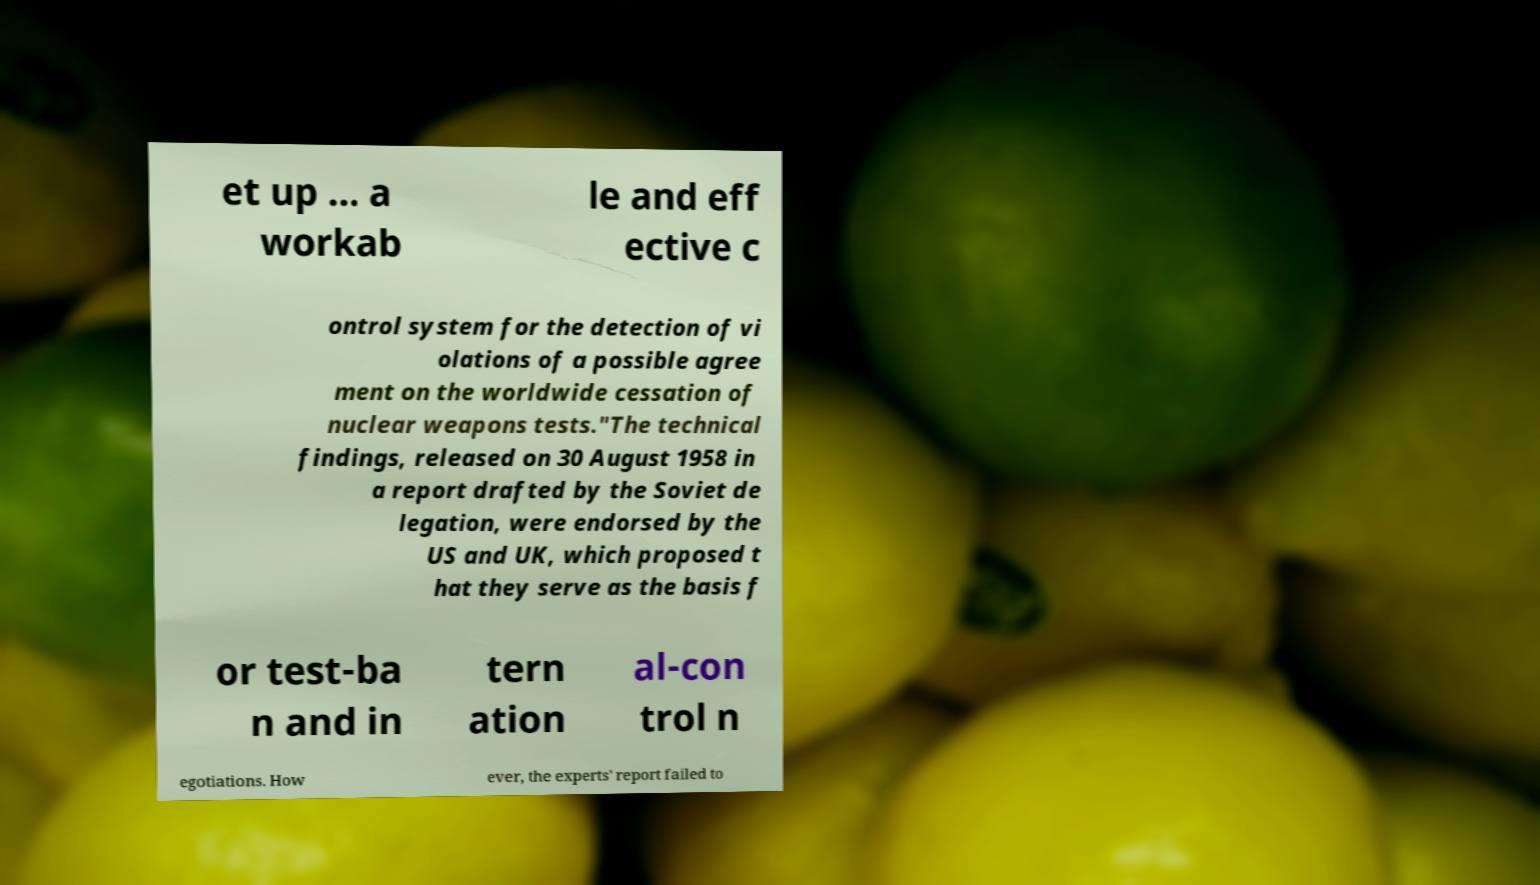Please identify and transcribe the text found in this image. et up ... a workab le and eff ective c ontrol system for the detection of vi olations of a possible agree ment on the worldwide cessation of nuclear weapons tests."The technical findings, released on 30 August 1958 in a report drafted by the Soviet de legation, were endorsed by the US and UK, which proposed t hat they serve as the basis f or test-ba n and in tern ation al-con trol n egotiations. How ever, the experts' report failed to 